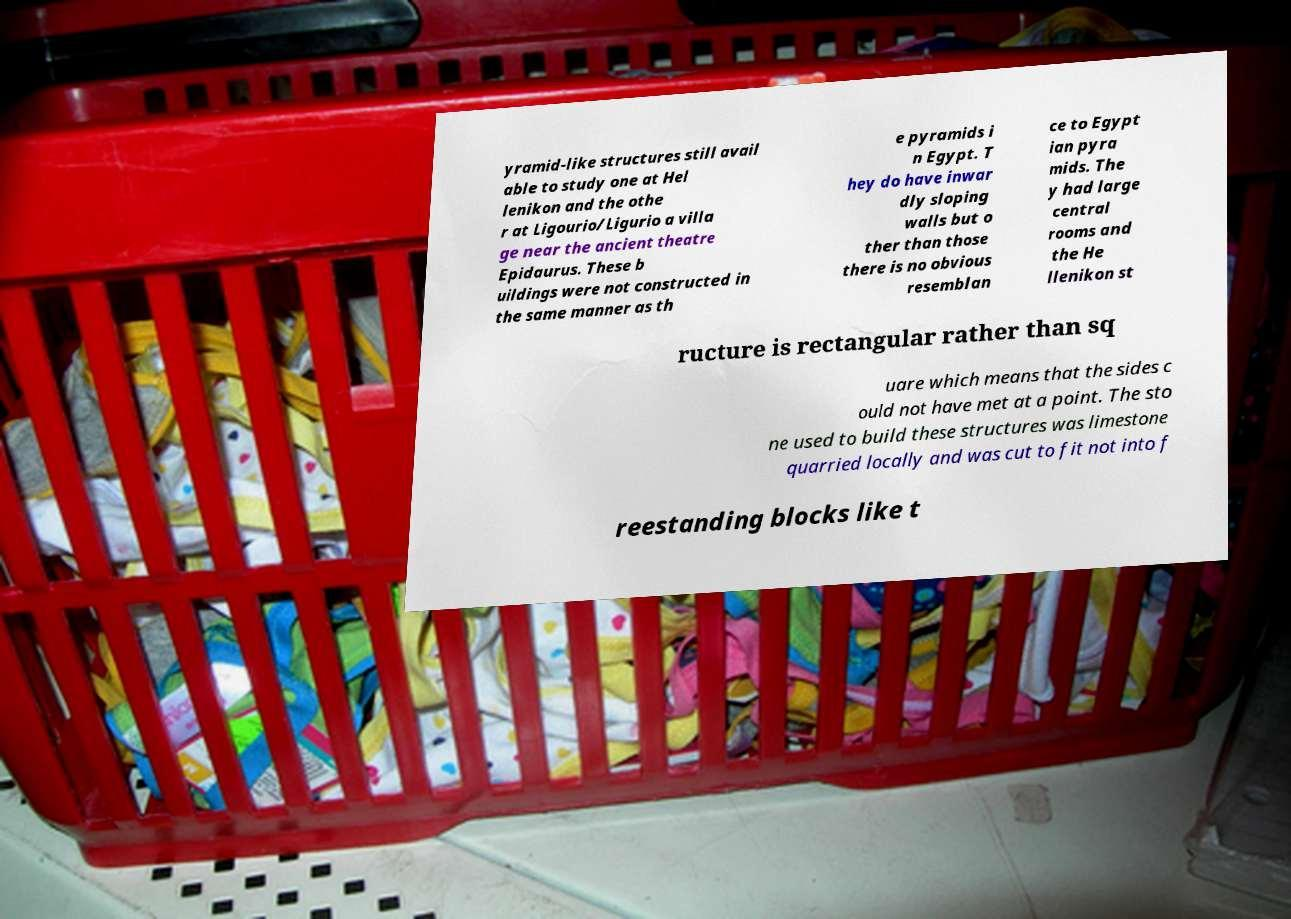Can you accurately transcribe the text from the provided image for me? yramid-like structures still avail able to study one at Hel lenikon and the othe r at Ligourio/Ligurio a villa ge near the ancient theatre Epidaurus. These b uildings were not constructed in the same manner as th e pyramids i n Egypt. T hey do have inwar dly sloping walls but o ther than those there is no obvious resemblan ce to Egypt ian pyra mids. The y had large central rooms and the He llenikon st ructure is rectangular rather than sq uare which means that the sides c ould not have met at a point. The sto ne used to build these structures was limestone quarried locally and was cut to fit not into f reestanding blocks like t 